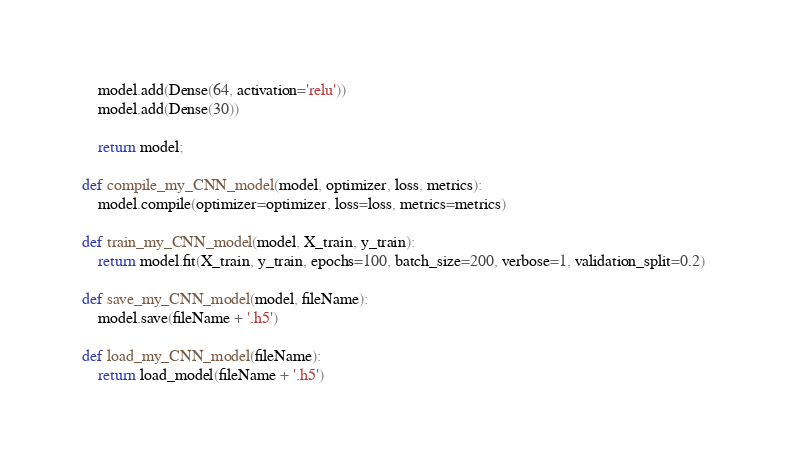Convert code to text. <code><loc_0><loc_0><loc_500><loc_500><_Python_>    model.add(Dense(64, activation='relu'))
    model.add(Dense(30))

    return model;

def compile_my_CNN_model(model, optimizer, loss, metrics):
    model.compile(optimizer=optimizer, loss=loss, metrics=metrics)

def train_my_CNN_model(model, X_train, y_train):
    return model.fit(X_train, y_train, epochs=100, batch_size=200, verbose=1, validation_split=0.2)

def save_my_CNN_model(model, fileName):
    model.save(fileName + '.h5')

def load_my_CNN_model(fileName):
    return load_model(fileName + '.h5')
</code> 